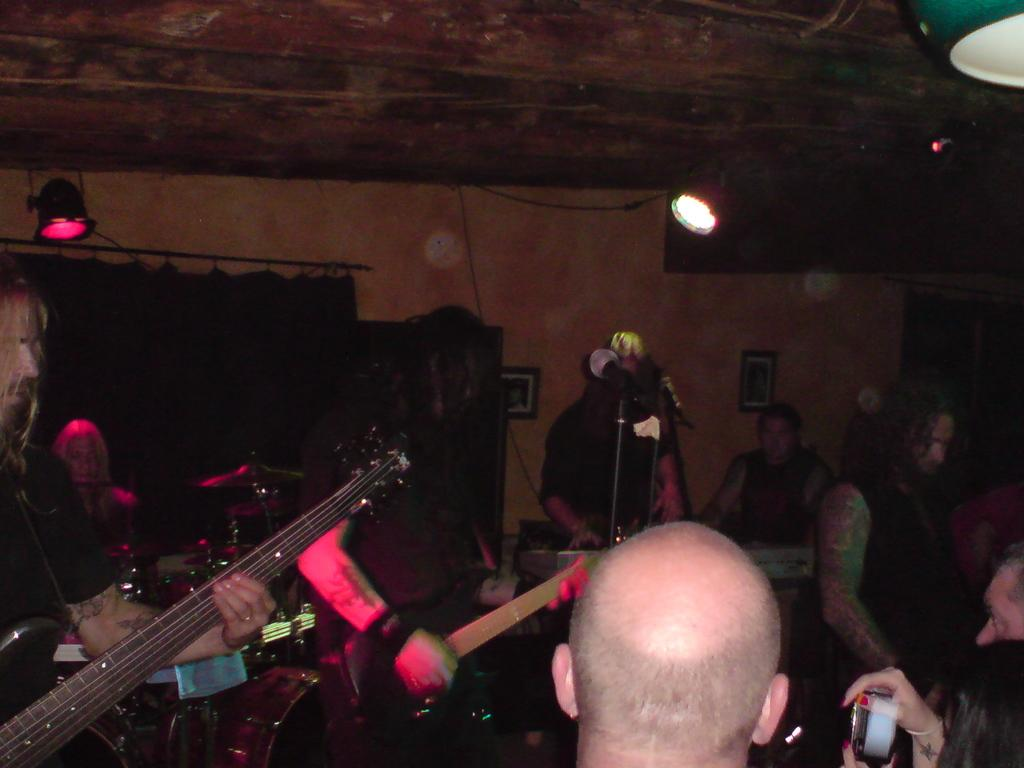How many people are present in the image? There are many people in the image. What are the people doing in the image? The people are gathered together. Are any musical instruments visible in the image? Yes, some people are holding guitars, and there is a man playing a Casio. Can you see any ants carrying bricks in the image? No, there are no ants or bricks present in the image. Is anyone running in the image? The provided facts do not mention anyone running in the image. 